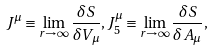Convert formula to latex. <formula><loc_0><loc_0><loc_500><loc_500>J ^ { \mu } \equiv \lim _ { r \to \infty } \frac { \delta S } { \delta V _ { \mu } } , J ^ { \mu } _ { 5 } \equiv \lim _ { r \to \infty } \frac { \delta S } { \delta A _ { \mu } } ,</formula> 